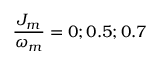Convert formula to latex. <formula><loc_0><loc_0><loc_500><loc_500>\frac { J _ { m } } { \omega _ { m } } = 0 ; 0 . 5 ; 0 . 7</formula> 